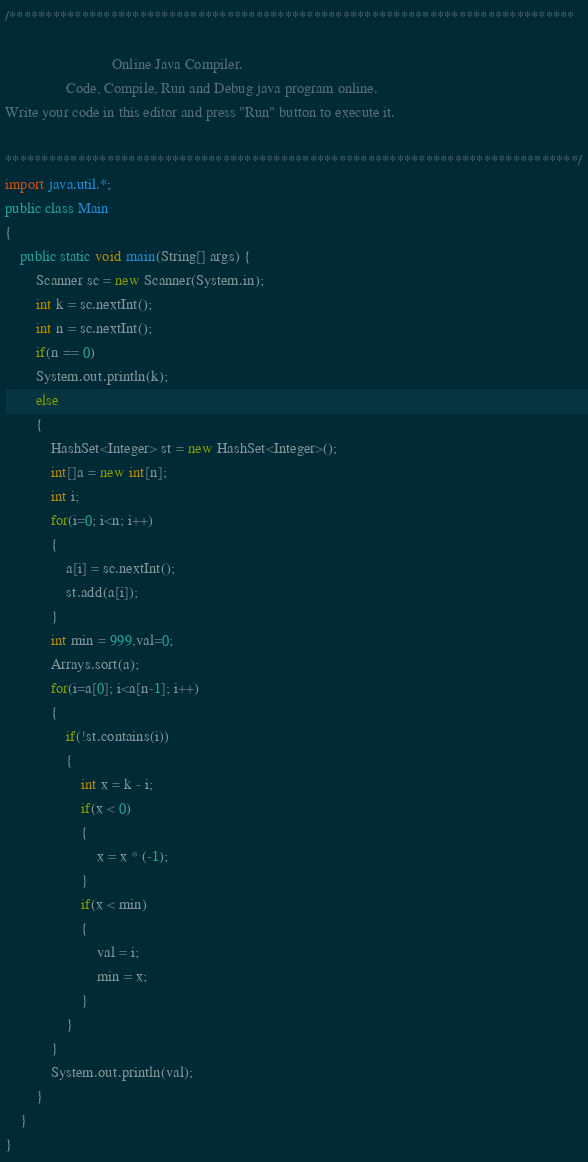<code> <loc_0><loc_0><loc_500><loc_500><_Java_>/******************************************************************************

                            Online Java Compiler.
                Code, Compile, Run and Debug java program online.
Write your code in this editor and press "Run" button to execute it.

*******************************************************************************/
import java.util.*;
public class Main
{
	public static void main(String[] args) {
		Scanner sc = new Scanner(System.in);
		int k = sc.nextInt();
		int n = sc.nextInt();
		if(n == 0)
		System.out.println(k);
		else
		{
		    HashSet<Integer> st = new HashSet<Integer>();
		    int[]a = new int[n];
		    int i;
		    for(i=0; i<n; i++)
		    {
		        a[i] = sc.nextInt();
		        st.add(a[i]);
		    }
		    int min = 999,val=0;
		    Arrays.sort(a);
		    for(i=a[0]; i<a[n-1]; i++)
		    {
		        if(!st.contains(i))
		        {
		            int x = k - i;
		            if(x < 0)
		            {
		                x = x * (-1);
		            }
		            if(x < min)
		            {
		                val = i;
		                min = x;
		            }
		        }
		    }
		    System.out.println(val);
		}
	}
}
</code> 